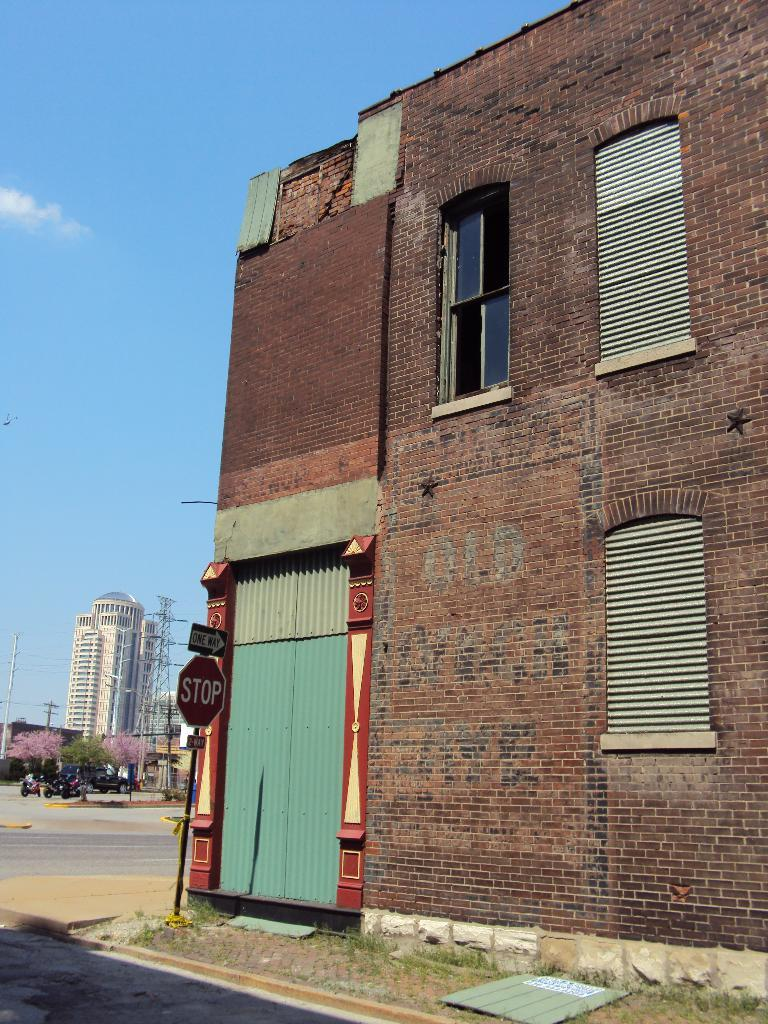What type of structure is visible in the image? There is a house in the image. What can be seen in the middle of the image? There is a stop sign board in the middle of the image. What is visible at the top of the image? The sky is visible at the top of the image. Can you describe the rock formation* in the wilderness near the house? There is no rock formation or wilderness present in the image; it features a house and a stop sign board. 